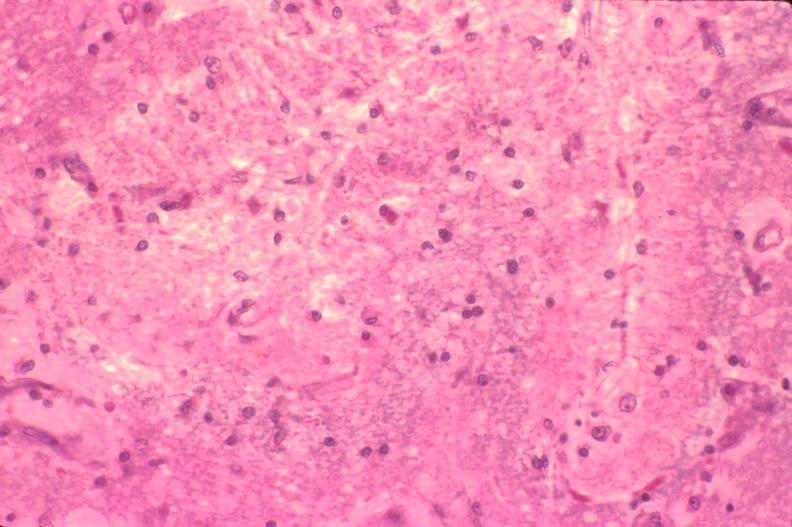what does this image show?
Answer the question using a single word or phrase. Brain 